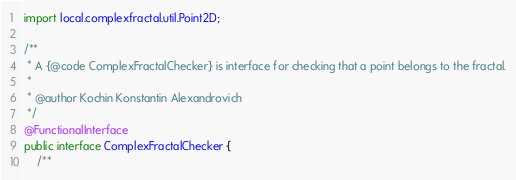Convert code to text. <code><loc_0><loc_0><loc_500><loc_500><_Java_>
import local.complexfractal.util.Point2D;

/**
 * A {@code ComplexFractalChecker} is interface for checking that a point belongs to the fractal.
 *
 * @author Kochin Konstantin Alexandrovich
 */
@FunctionalInterface
public interface ComplexFractalChecker {
    /**</code> 